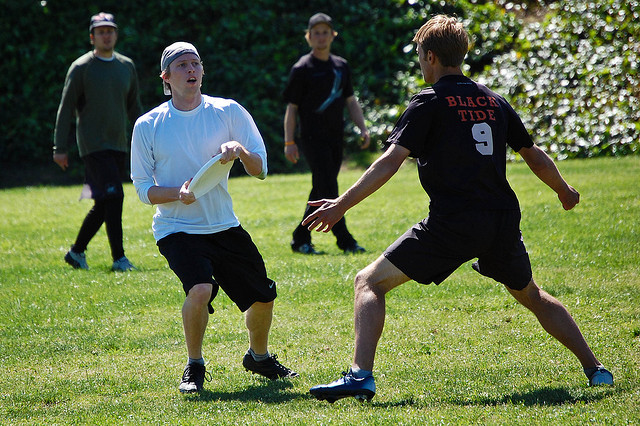Identify and read out the text in this image. 9 BLACK TIDE 